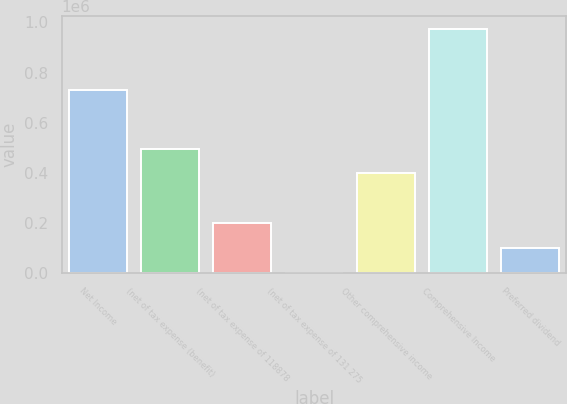Convert chart to OTSL. <chart><loc_0><loc_0><loc_500><loc_500><bar_chart><fcel>Net Income<fcel>(net of tax expense (benefit)<fcel>(net of tax expense of 118878<fcel>(net of tax expense of 131 275<fcel>Other comprehensive income<fcel>Comprehensive Income<fcel>Preferred dividend<nl><fcel>730572<fcel>497287<fcel>199061<fcel>243<fcel>397878<fcel>975661<fcel>99651.8<nl></chart> 